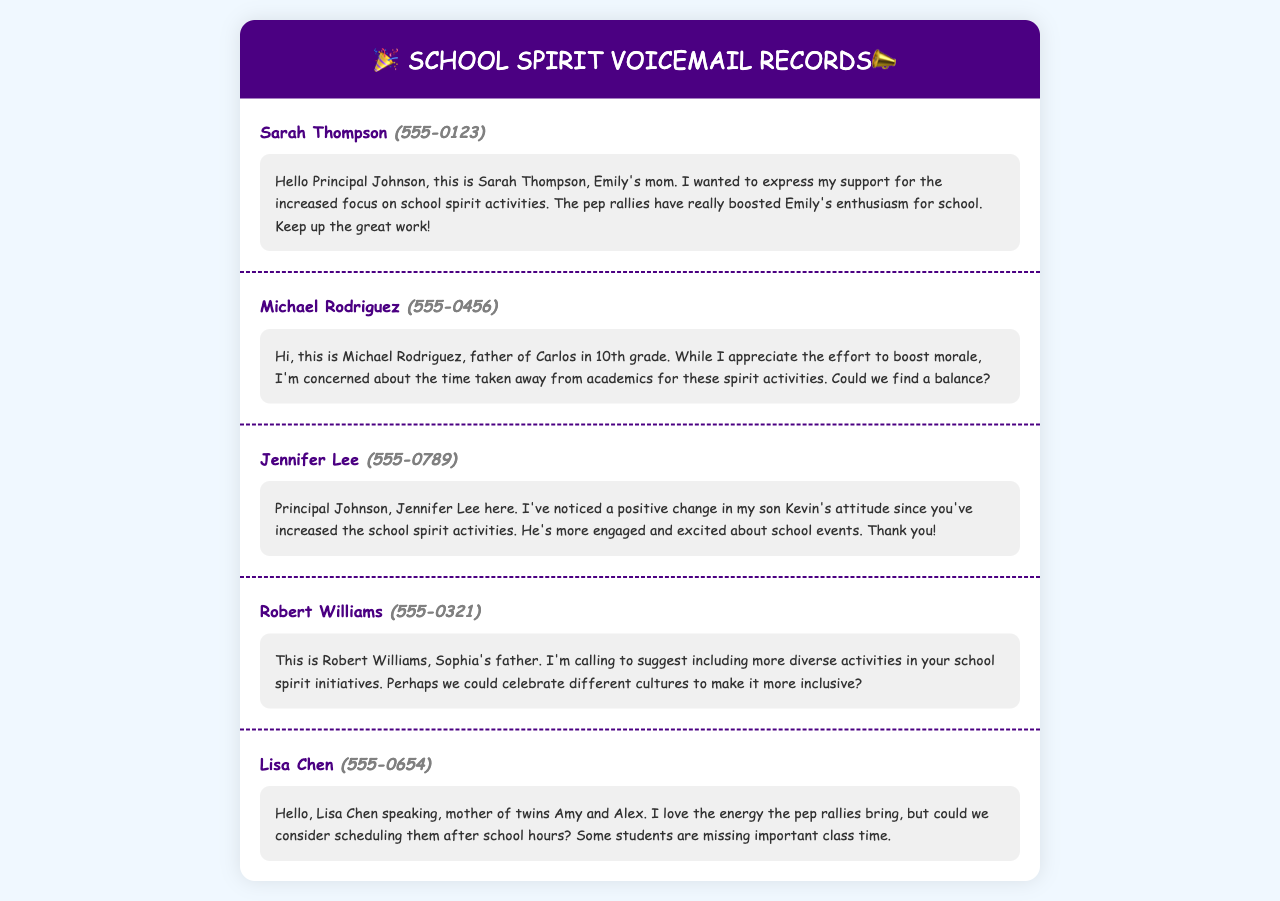What is the name of the parent who supports increased focus on school spirit activities? The name of the parent expressing support is Sarah Thompson.
Answer: Sarah Thompson Which student's parent is concerned about the balance between spirit activities and academics? The parent expressing concern about balance is Michael Rodriguez, father of Carlos.
Answer: Michael Rodriguez How did Jennifer Lee describe her son Kevin's attitude after the increase in school spirit activities? Jennifer Lee noted that Kevin's attitude has positively changed, indicating he is more engaged and excited.
Answer: More engaged and excited What suggestion did Robert Williams make regarding school spirit initiatives? Robert Williams suggested including more diverse activities to celebrate different cultures for inclusivity.
Answer: More diverse activities What concern did Lisa Chen express about the timing of pep rallies? Lisa Chen expressed concern that some students are missing important class time due to the scheduling of pep rallies.
Answer: Missing important class time 